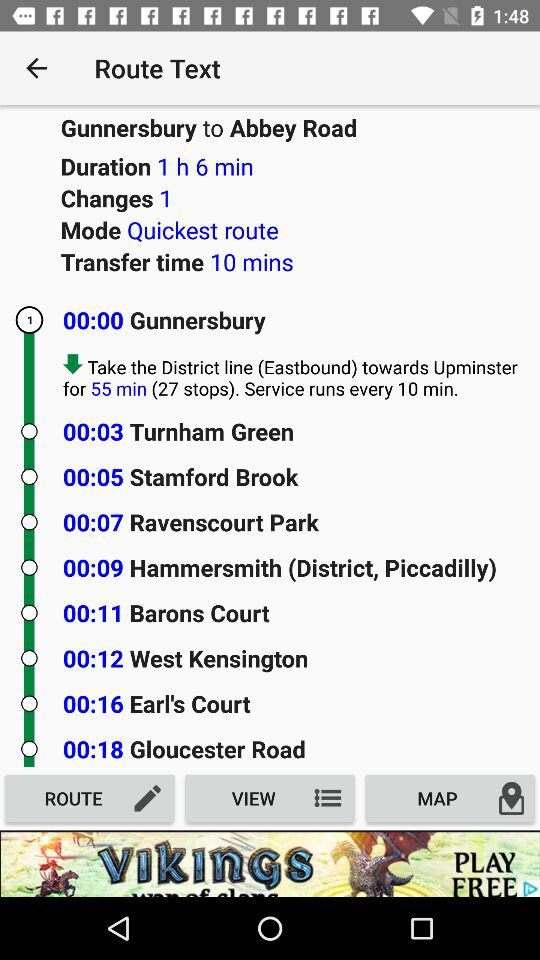How long will it take to get from Gunnersbury to Abbey Road?
Answer the question using a single word or phrase. 1 hour 6 minutes 